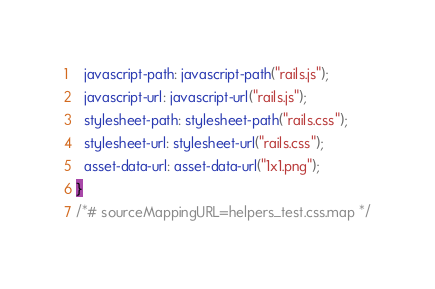<code> <loc_0><loc_0><loc_500><loc_500><_CSS_>  javascript-path: javascript-path("rails.js");
  javascript-url: javascript-url("rails.js");
  stylesheet-path: stylesheet-path("rails.css");
  stylesheet-url: stylesheet-url("rails.css");
  asset-data-url: asset-data-url("1x1.png");
}
/*# sourceMappingURL=helpers_test.css.map */</code> 